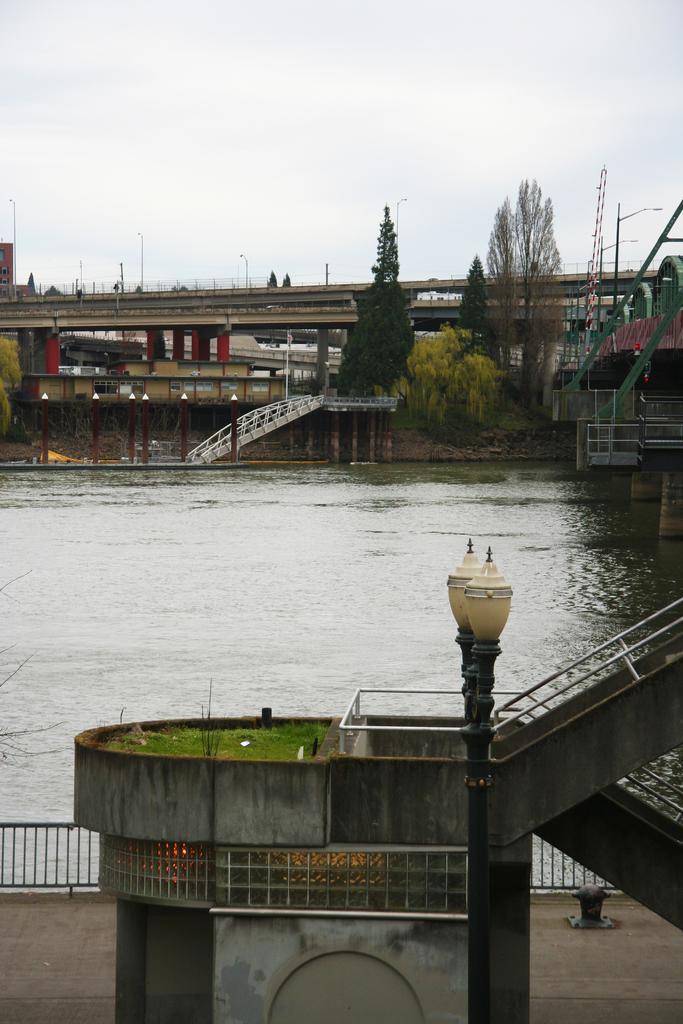Please provide a concise description of this image. In this image we can see bridge, iron grill, trees, rocks, street poles, street lights, water and sky with clouds. 